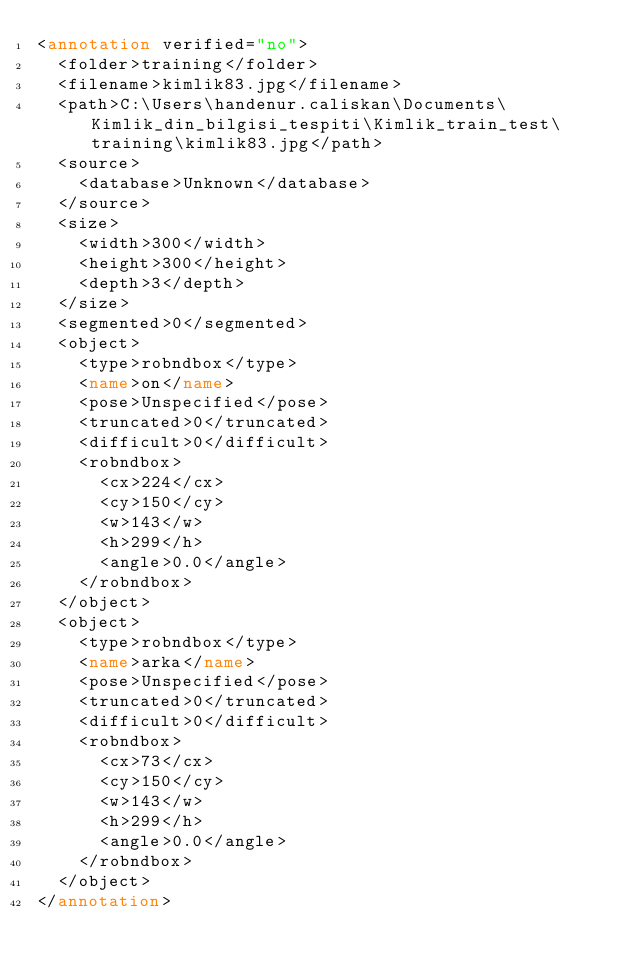<code> <loc_0><loc_0><loc_500><loc_500><_XML_><annotation verified="no">
  <folder>training</folder>
  <filename>kimlik83.jpg</filename>
  <path>C:\Users\handenur.caliskan\Documents\Kimlik_din_bilgisi_tespiti\Kimlik_train_test\training\kimlik83.jpg</path>
  <source>
    <database>Unknown</database>
  </source>
  <size>
    <width>300</width>
    <height>300</height>
    <depth>3</depth>
  </size>
  <segmented>0</segmented>
  <object>
    <type>robndbox</type>
    <name>on</name>
    <pose>Unspecified</pose>
    <truncated>0</truncated>
    <difficult>0</difficult>
    <robndbox>
      <cx>224</cx>
      <cy>150</cy>
      <w>143</w>
      <h>299</h>
      <angle>0.0</angle>
    </robndbox>
  </object>
  <object>
    <type>robndbox</type>
    <name>arka</name>
    <pose>Unspecified</pose>
    <truncated>0</truncated>
    <difficult>0</difficult>
    <robndbox>
      <cx>73</cx>
      <cy>150</cy>
      <w>143</w>
      <h>299</h>
      <angle>0.0</angle>
    </robndbox>
  </object>
</annotation></code> 